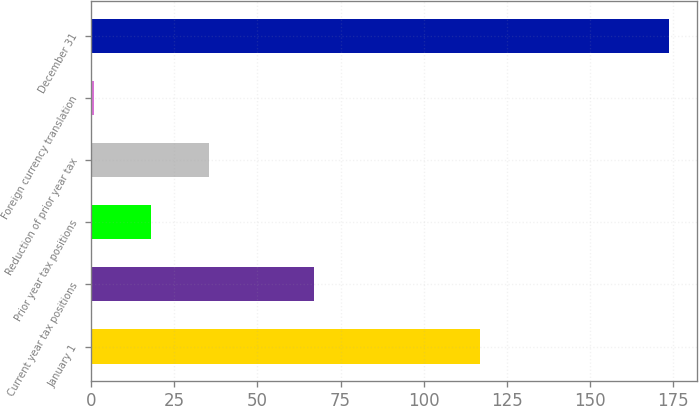Convert chart to OTSL. <chart><loc_0><loc_0><loc_500><loc_500><bar_chart><fcel>January 1<fcel>Current year tax positions<fcel>Prior year tax positions<fcel>Reduction of prior year tax<fcel>Foreign currency translation<fcel>December 31<nl><fcel>116.9<fcel>67.1<fcel>18<fcel>35.3<fcel>0.7<fcel>173.7<nl></chart> 